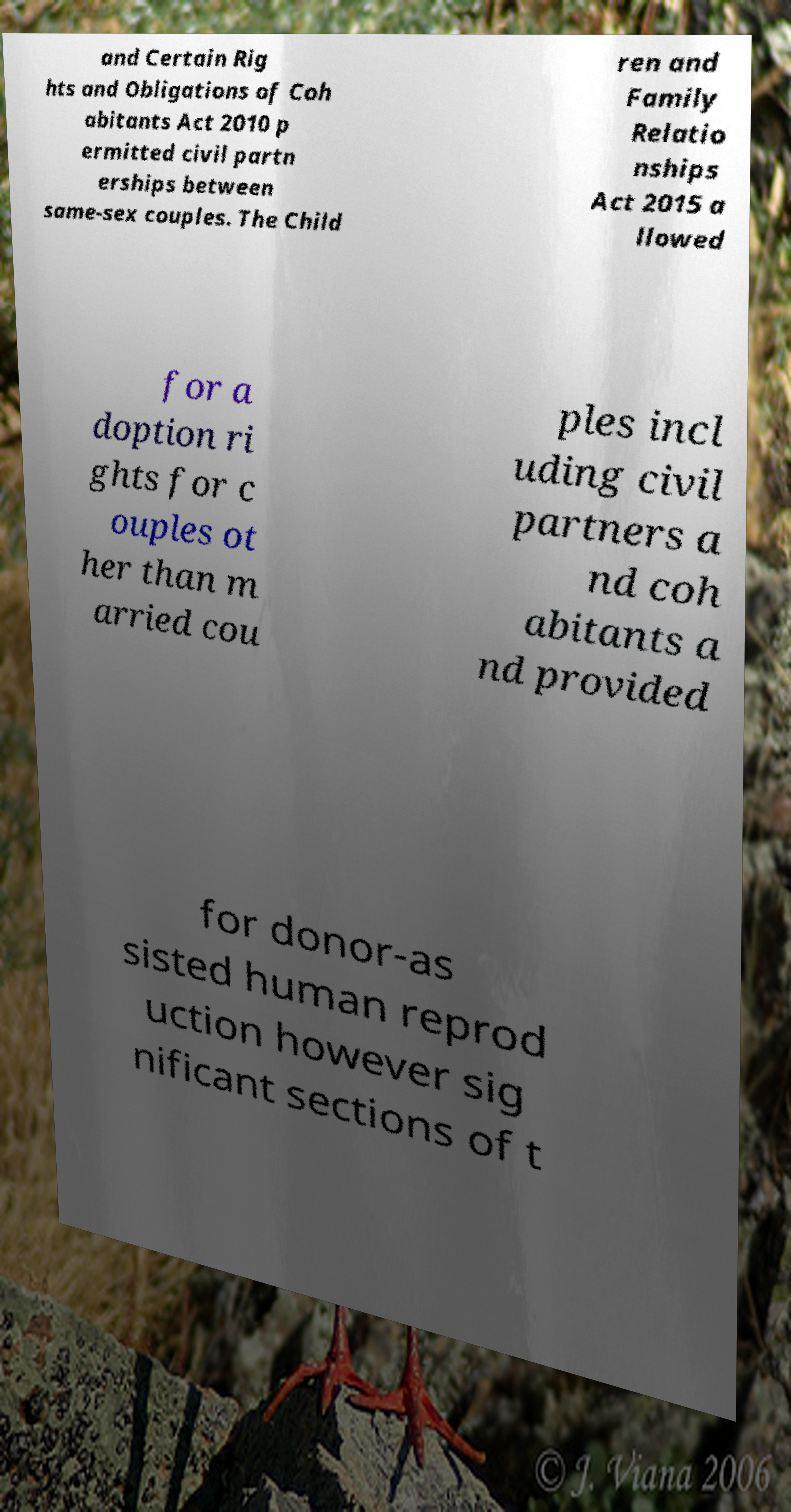Could you assist in decoding the text presented in this image and type it out clearly? and Certain Rig hts and Obligations of Coh abitants Act 2010 p ermitted civil partn erships between same-sex couples. The Child ren and Family Relatio nships Act 2015 a llowed for a doption ri ghts for c ouples ot her than m arried cou ples incl uding civil partners a nd coh abitants a nd provided for donor-as sisted human reprod uction however sig nificant sections of t 